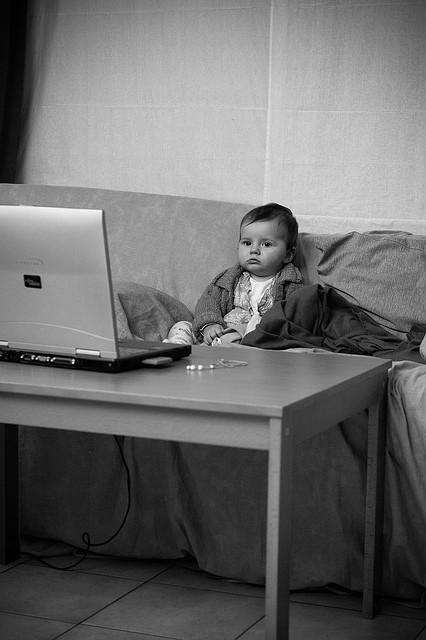How many tablecloths have been used?
Give a very brief answer. 0. How many laptops are there?
Give a very brief answer. 1. How many oranges can be seen in the bottom box?
Give a very brief answer. 0. 